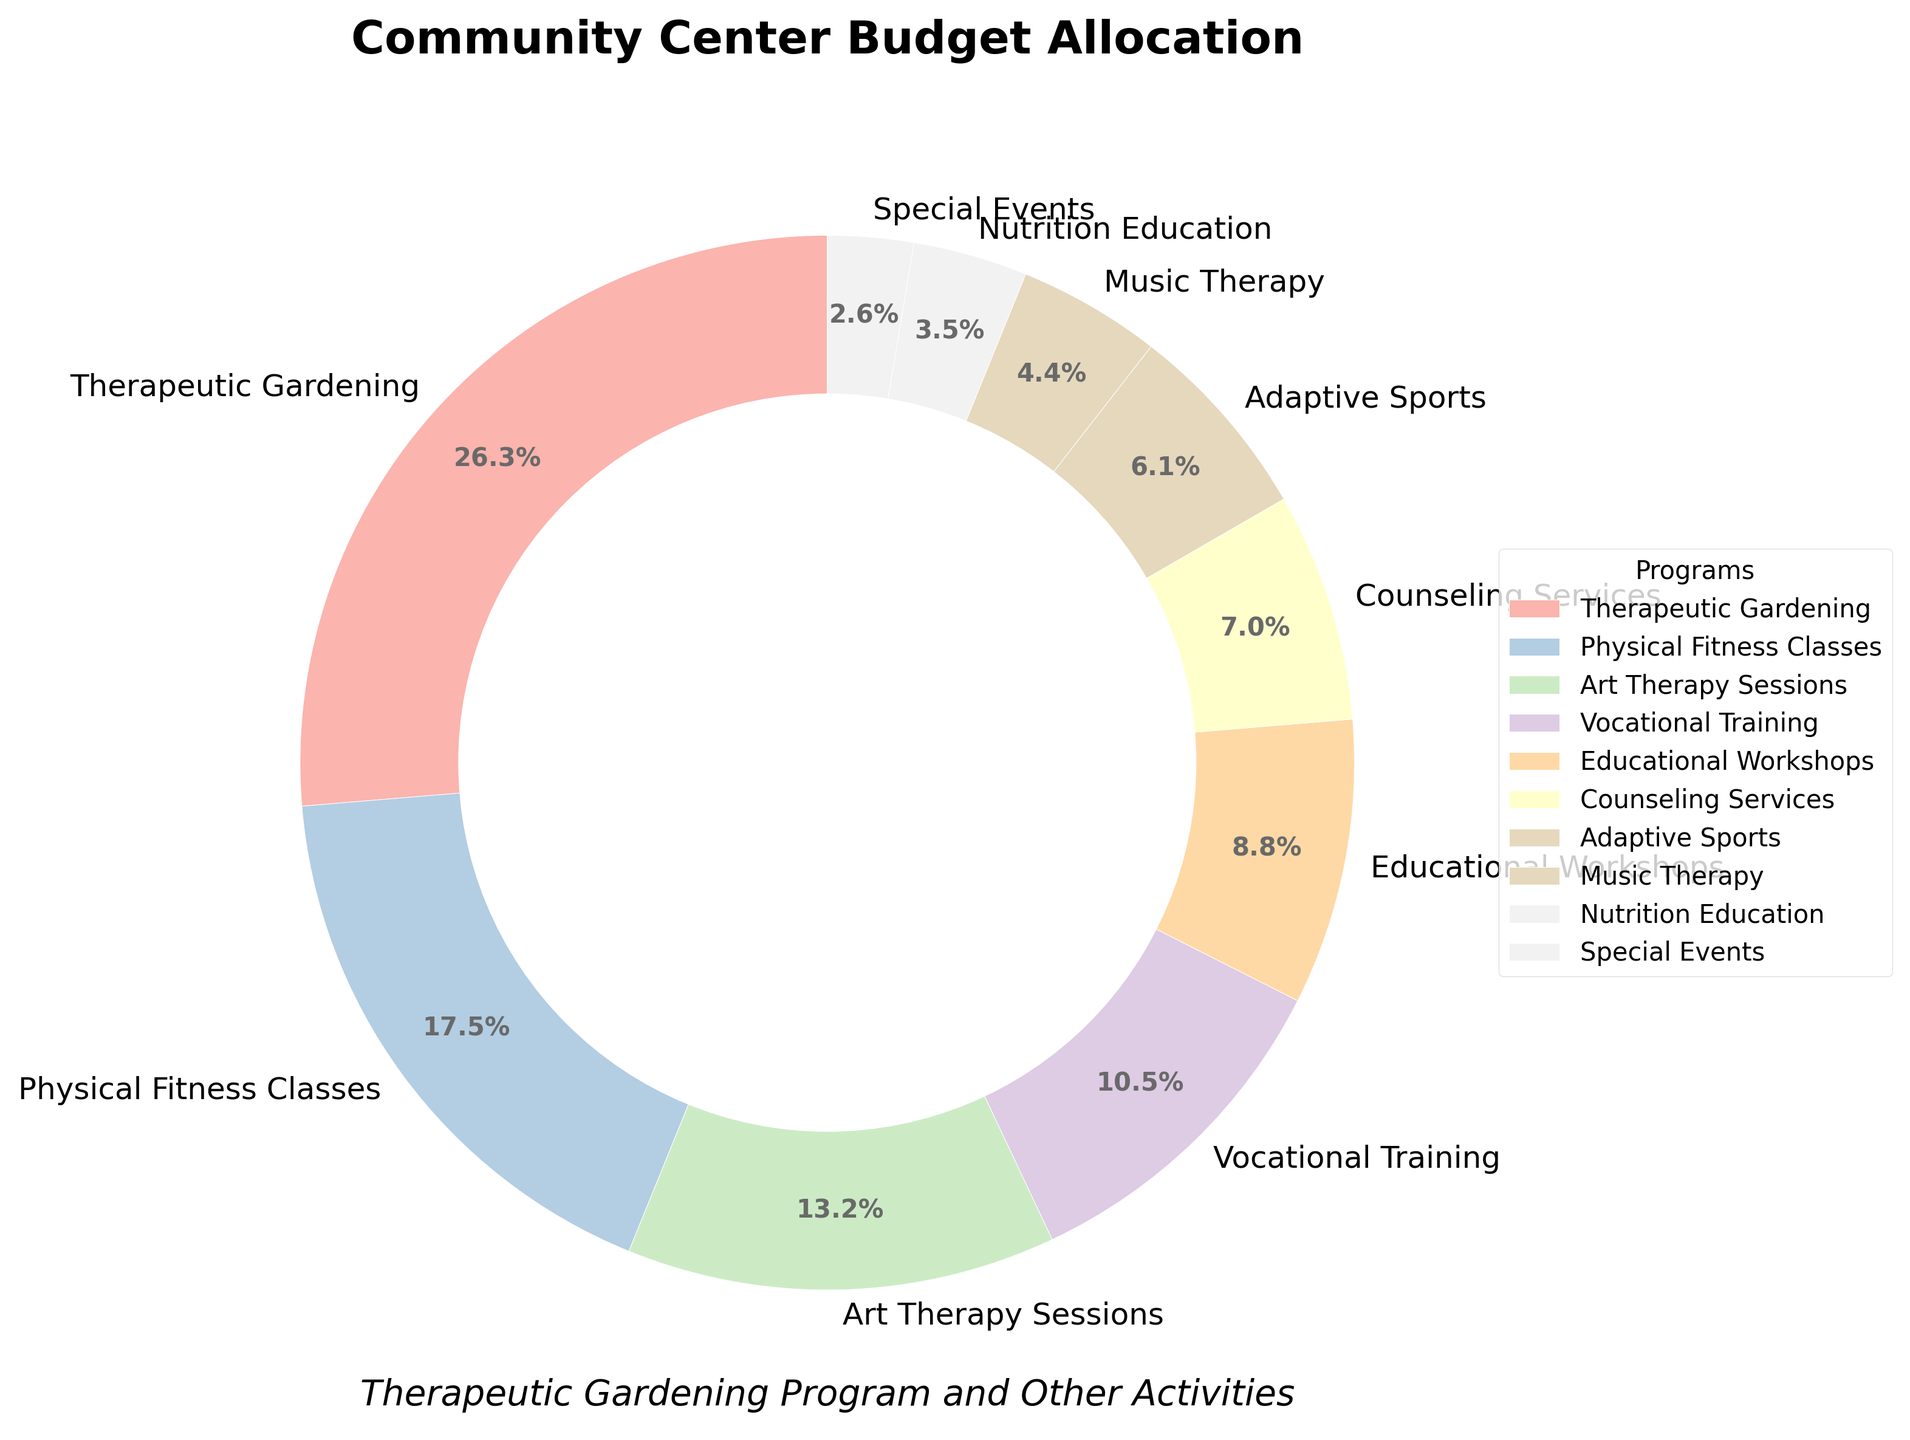What percentage of the budget is allocated to Therapeutic Gardening? From the pie chart, the percentage allocation for Therapeutic Gardening can be directly read. It's labeled as 30%.
Answer: 30% Which program receives the least budget allocation? By looking at the smallest wedge in the pie chart, we can see that Special Events receive the smallest allocation, labeled as 3%.
Answer: Special Events How much more budget allocation does Physical Fitness Classes receive compared to Music Therapy? The chart shows that Physical Fitness Classes receive 20% and Music Therapy receives 5%. The difference is 20% - 5% = 15%.
Answer: 15% What is the combined budget allocation for Educational Workshops, Counseling Services, and Adaptive Sports? From the chart, Educational Workshops have 10%, Counseling Services have 8%, and Adaptive Sports have 7%. Summing these, 10% + 8% + 7% = 25%.
Answer: 25% Which programs have a budget allocation less than 10%? The programs labeled with budget allocations less than 10% are: Counseling Services (8%), Adaptive Sports (7%), Music Therapy (5%), Nutrition Education (4%), and Special Events (3%).
Answer: Counseling Services, Adaptive Sports, Music Therapy, Nutrition Education, Special Events What is the difference in budget allocation between the highest and lowest funded programs? The highest funded program is Therapeutic Gardening with 30%, and the lowest funded program is Special Events with 3%. The difference is 30% - 3% = 27%.
Answer: 27% How does the budget allocation for Vocational Training compare to Art Therapy Sessions? The chart shows Vocational Training is allocated 12% and Art Therapy Sessions are allocated 15%. Art Therapy Sessions receive 3% more budget allocation than Vocational Training.
Answer: Art Therapy Sessions receive 3% more Is the budget allocation for Therapeutic Gardening more than the combined allocation for Adaptive Sports and Music Therapy? Adaptive Sports have 7% and Music Therapy has 5%, giving a combined total of 12%. Therapeutic Gardening has 30%, which is more than 12%.
Answer: Yes, more How many programs have a budget allocation of at least 10%? From the chart, the programs with at least 10% are: Therapeutic Gardening (30%), Physical Fitness Classes (20%), Art Therapy Sessions (15%), and Vocational Training (12%), Educational Workshops (10%). That makes 5 programs.
Answer: 5 programs If 60% of the budget is yet to be allocated, which programs together will make it 100% if added to the therapeutic gardening program? Therapeutic Gardening has 30%, thus needing an additional 70% to make 100%. Adding Physical Fitness Classes (20%), Art Therapy Sessions (15%), Vocational Training (12%), and Educational Workshops (10%) together gives 57%. Remaining 13% can be achieved with Counseling Services (8%) and Adaptive Sports (7%). All except Special Events, Nutrition Education, and Music Therapy make it up to 100%.
Answer: Physical Fitness Classes, Art Therapy Sessions, Vocational Training, Educational Workshops, Counseling Services, Adaptive Sports 